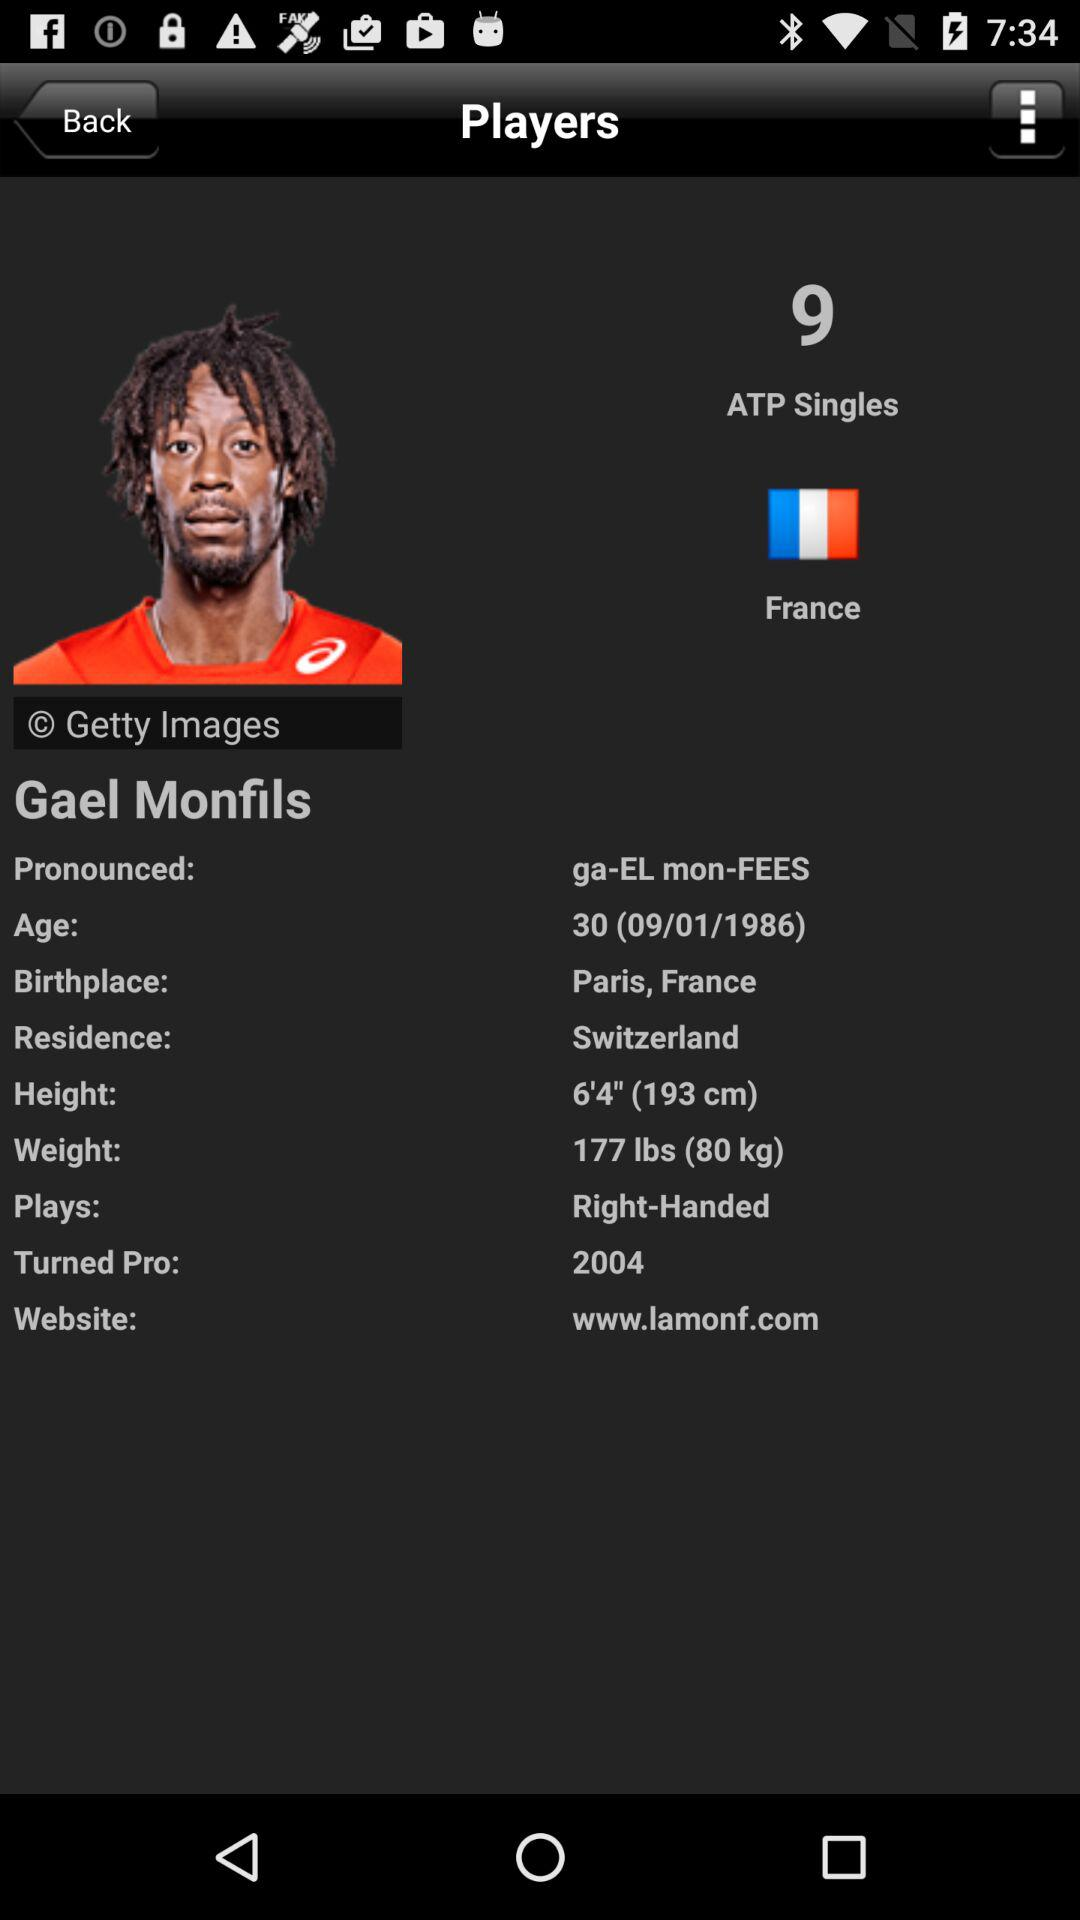What is the age of the player? The player is 30 years old. 